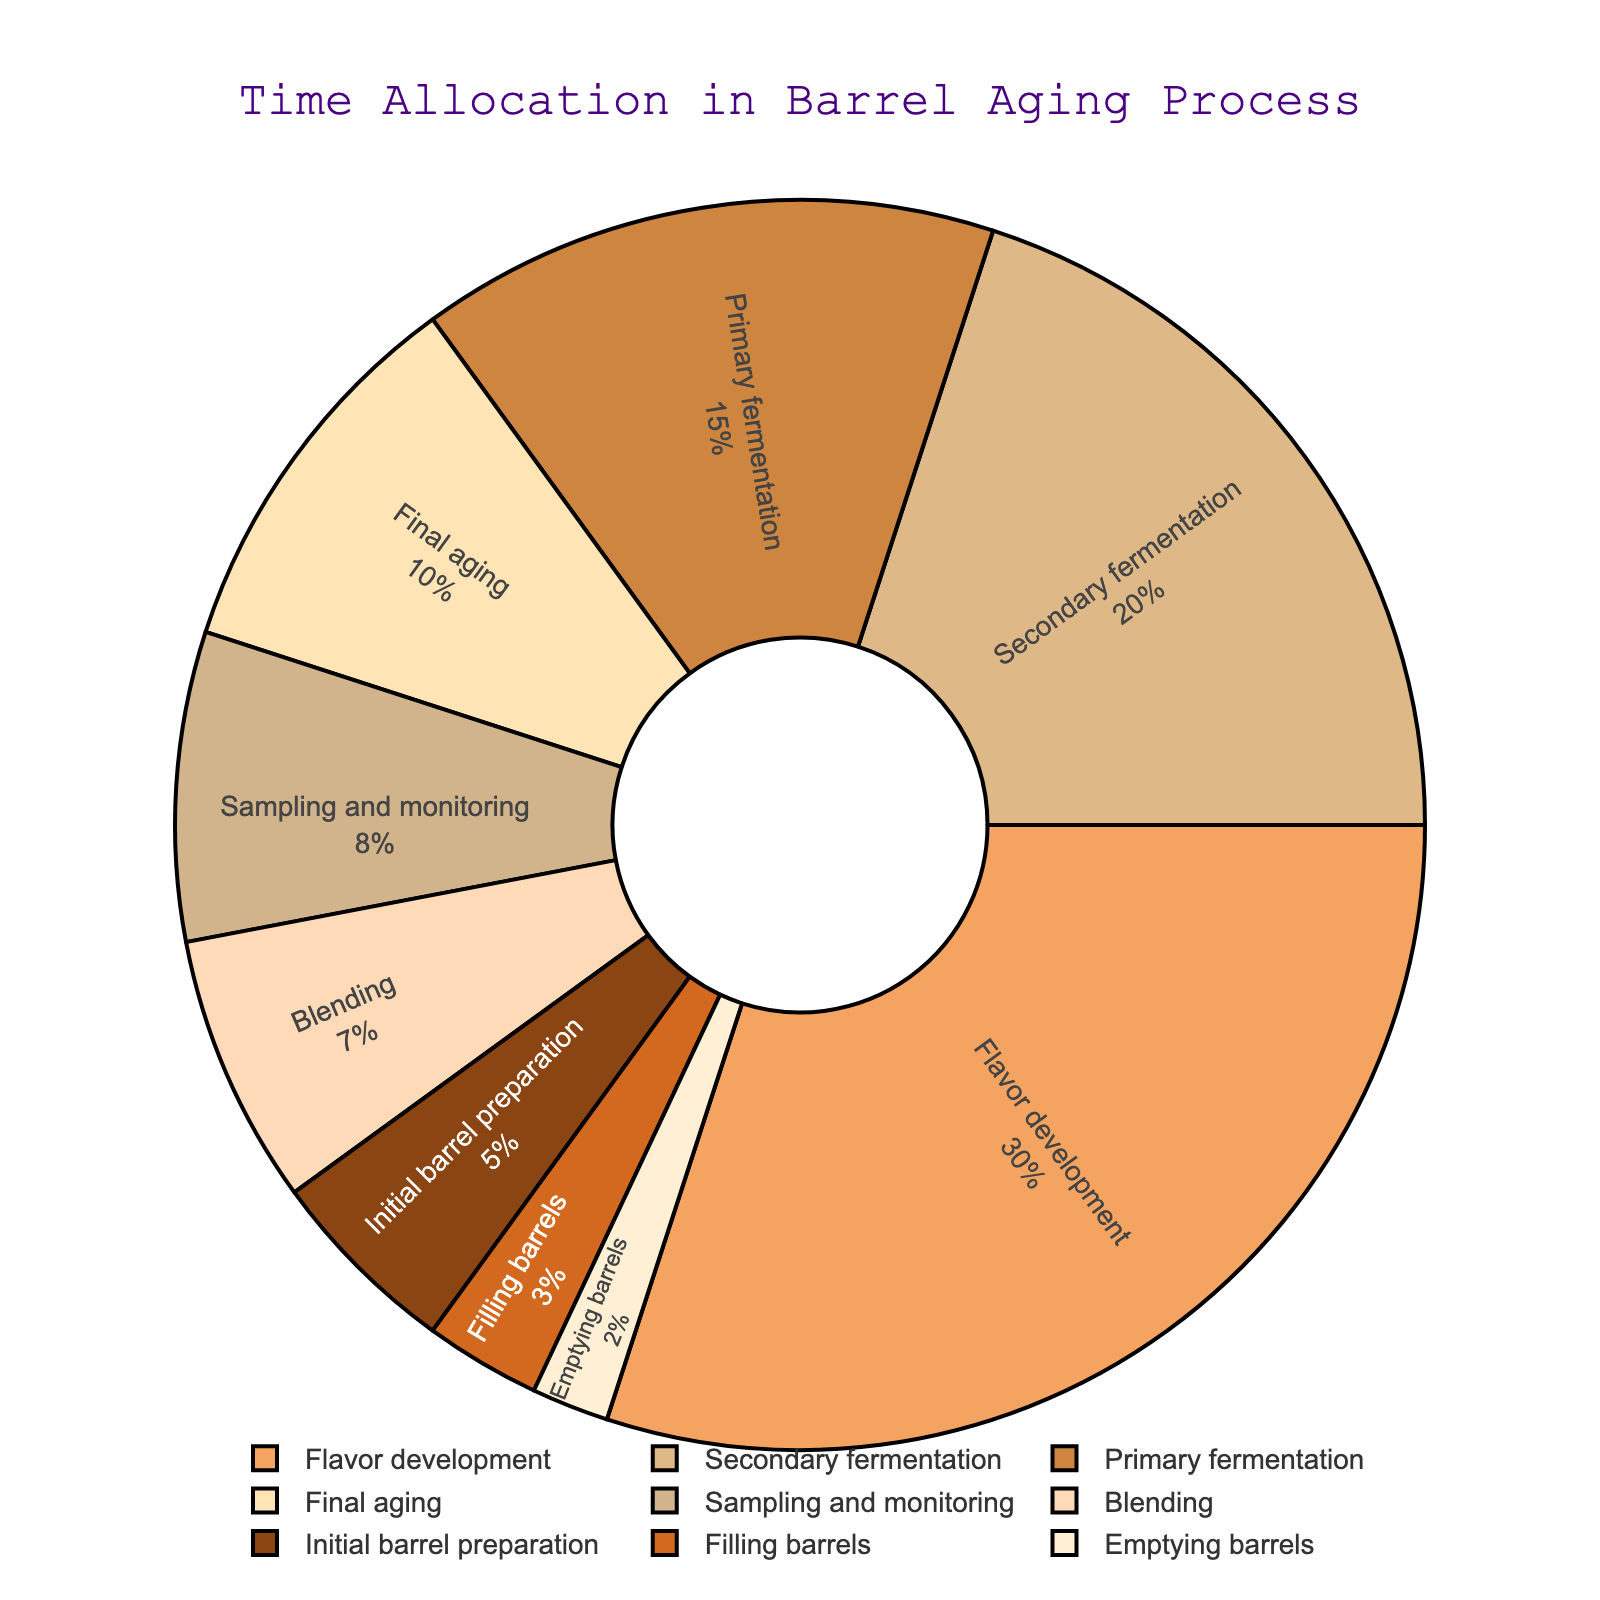What stage of the barrel aging process takes the most time? By observing the figure, we can see that "Flavor development" has the largest slice of the pie chart, indicating it takes the most time.
Answer: Flavor development How much more time is spent on primary fermentation compared to emptying barrels? "Primary fermentation" occupies 15%, while "Emptying barrels" occupies 2%. The difference is 15% - 2% = 13%.
Answer: 13% What is the combined percentage of time allocated to secondary fermentation and final aging? "Secondary fermentation" accounts for 20%, and "Final aging" accounts for 10%. Adding these together gives 20% + 10% = 30%.
Answer: 30% Which stage takes less time: sampling and monitoring or blending? "Sampling and monitoring" occupies 8%, while "Blending" occupies 7%. Comparing these, we see that blending takes less time.
Answer: Blending What stages combined take up one-third of the total time allocation? We need to find stages that add up to approximately 33.3%. "Primary fermentation" (15%), "Sampling and monitoring" (8%), and "Blending" (7%) together account for 15% + 8% + 7% = 30%, which is close to 33.3%. Another combination could be "Final aging" (10%) plus "Secondary fermentation" (20%), totaling 30%, which is also a reasonable match based on closest combined values available in the plot.
Answer: Primary fermentation, Sampling and monitoring, Blending Are there any stages that occupy equal proportions in the barrel aging process? Looking at the pie chart, no stages have exactly the same percentage assigned to them. Each slice is distinct in size.
Answer: No Which visual attribute indicates the differences in time allocation among the stages? The size (or area) of each slice in the pie chart represents the proportional time allocation for each stage. Larger slices indicate more time allocated.
Answer: Size of slices How does the time spent on initial barrel preparation compare to the time spent on final aging? "Initial barrel preparation" occupies 5%, and "Final aging" occupies 10%. Therefore, final aging takes twice as much time as initial barrel preparation.
Answer: Final aging takes twice as much time 